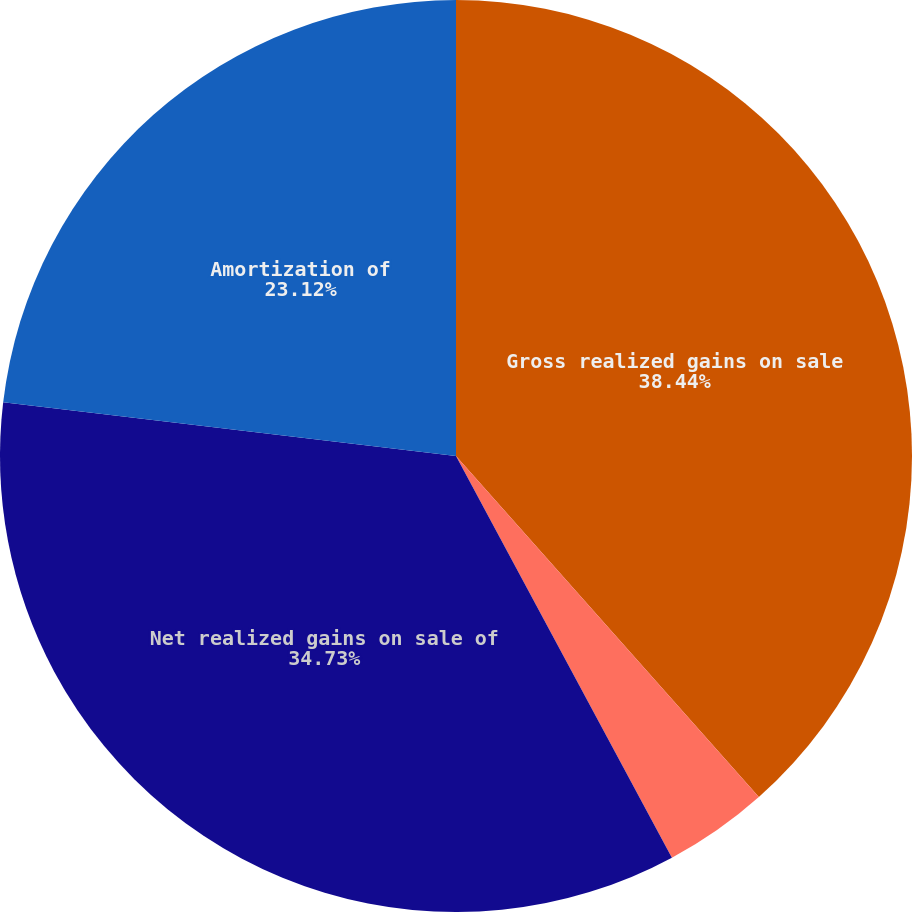Convert chart. <chart><loc_0><loc_0><loc_500><loc_500><pie_chart><fcel>Gross realized gains on sale<fcel>Gross realized losses on sale<fcel>Net realized gains on sale of<fcel>Amortization of<nl><fcel>38.44%<fcel>3.71%<fcel>34.73%<fcel>23.12%<nl></chart> 